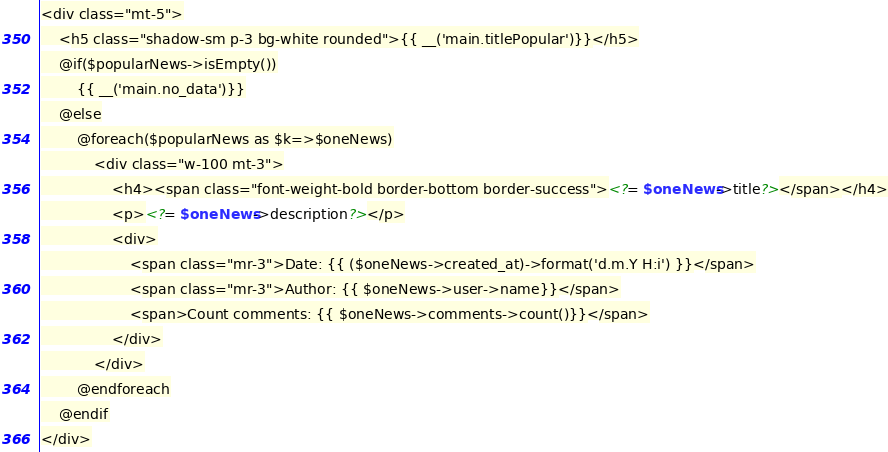<code> <loc_0><loc_0><loc_500><loc_500><_PHP_><div class="mt-5">
    <h5 class="shadow-sm p-3 bg-white rounded">{{ __('main.titlePopular')}}</h5>
	@if($popularNews->isEmpty())
		{{ __('main.no_data')}}
	@else
		@foreach($popularNews as $k=>$oneNews)
			<div class="w-100 mt-3">
				<h4><span class="font-weight-bold border-bottom border-success"><?= $oneNews->title?></span></h4>
				<p><?= $oneNews->description?></p>
				<div>
					<span class="mr-3">Date: {{ ($oneNews->created_at)->format('d.m.Y H:i') }}</span>
					<span class="mr-3">Author: {{ $oneNews->user->name}}</span>
					<span>Count comments: {{ $oneNews->comments->count()}}</span>
				</div>
			</div>
		@endforeach
	@endif
</div></code> 